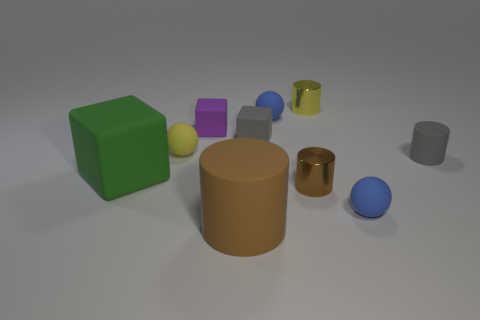There is a tiny brown cylinder; how many objects are behind it?
Your answer should be compact. 7. The other cylinder that is the same material as the gray cylinder is what color?
Offer a very short reply. Brown. Is the shape of the large brown thing the same as the purple object?
Offer a terse response. No. How many small things are both right of the small brown metal cylinder and behind the large green cube?
Your answer should be compact. 2. What number of rubber things are either big gray cylinders or balls?
Provide a short and direct response. 3. There is a brown rubber cylinder in front of the small blue rubber thing behind the green thing; what size is it?
Offer a terse response. Large. What is the material of the small block that is the same color as the small matte cylinder?
Ensure brevity in your answer.  Rubber. There is a blue matte object that is to the left of the tiny blue matte ball in front of the small gray rubber cylinder; are there any tiny blue objects behind it?
Give a very brief answer. No. Are the blue sphere behind the small rubber cylinder and the yellow thing behind the yellow rubber thing made of the same material?
Keep it short and to the point. No. What number of objects are gray cylinders or things that are behind the small gray cylinder?
Provide a succinct answer. 6. 